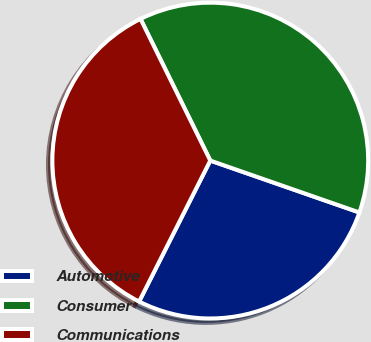<chart> <loc_0><loc_0><loc_500><loc_500><pie_chart><fcel>Automotive<fcel>Consumer<fcel>Communications<nl><fcel>27.11%<fcel>37.62%<fcel>35.28%<nl></chart> 